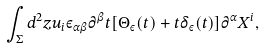<formula> <loc_0><loc_0><loc_500><loc_500>\int _ { \Sigma } d ^ { 2 } z u _ { i } \varepsilon _ { \alpha \beta } \partial ^ { \beta } t [ \Theta _ { \varepsilon } ( t ) + t \delta _ { \varepsilon } ( t ) ] \partial ^ { \alpha } X ^ { i } ,</formula> 